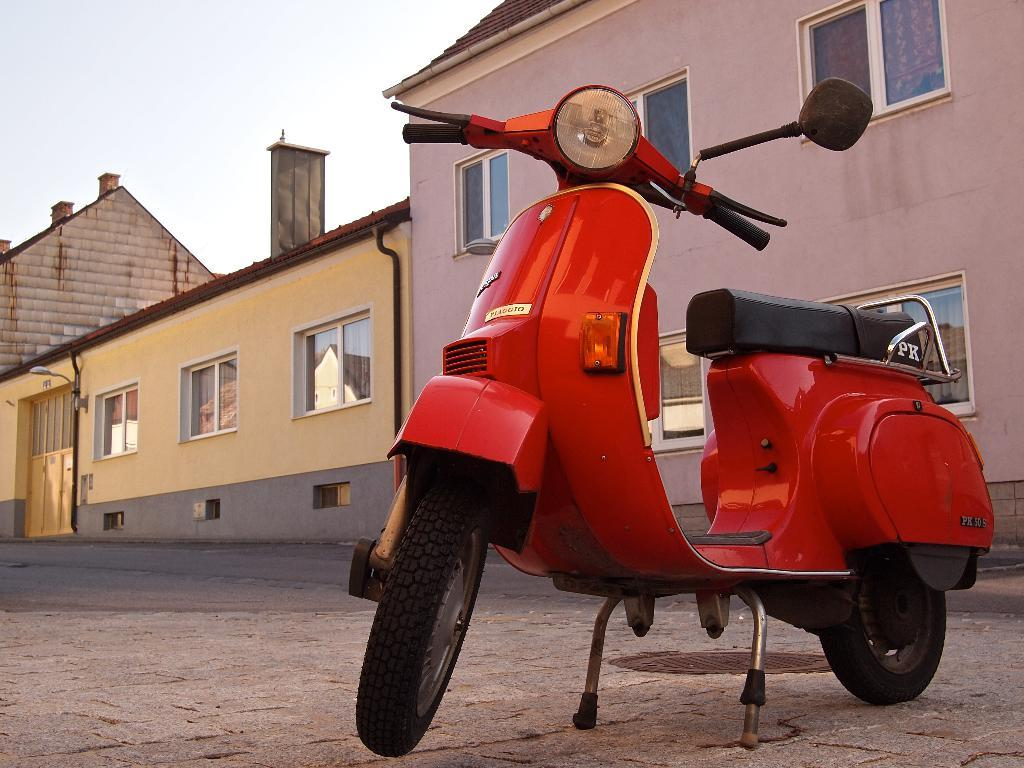What is the main subject of the image? The main subject of the image is a motorcycle. Can you describe the position of the motorcycle in the image? The motorcycle is on the ground in the image. What can be seen in the background of the image? There are buildings and the sky visible in the background of the image. What type of pear is being blown by the zephyr in the image? There is no pear or zephyr present in the image; it features a motorcycle on the ground with buildings and the sky in the background. 